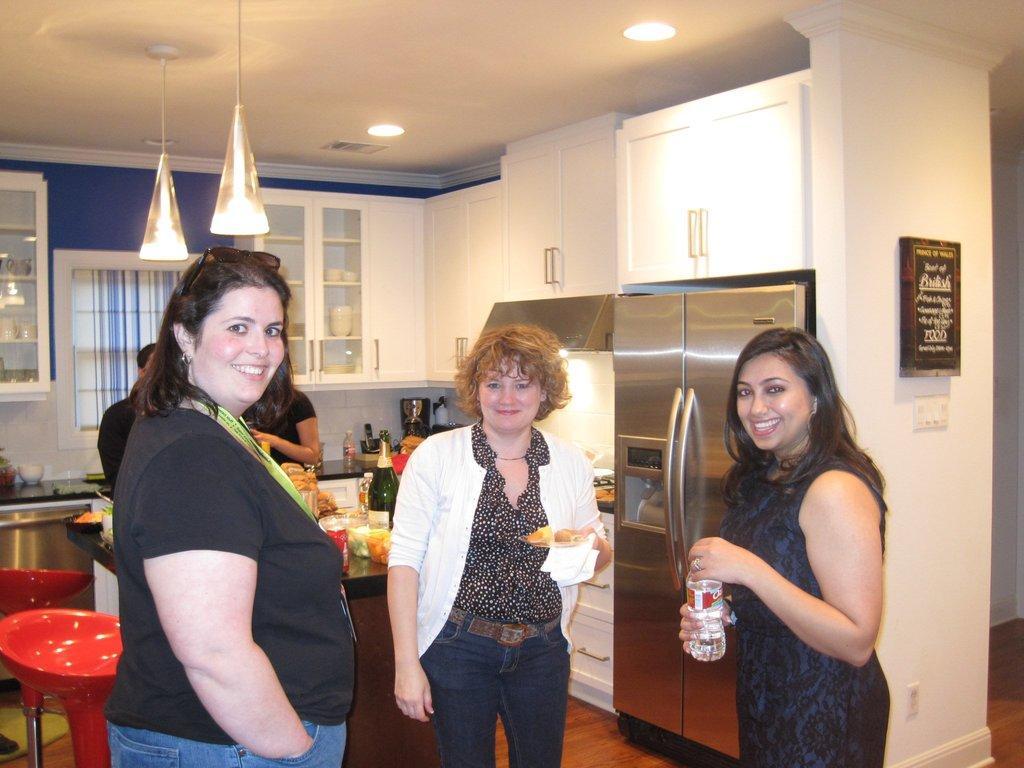How would you summarize this image in a sentence or two? In this image I can see a woman wearing black and blue colored dress, another woman wearing black, blue and white colored dress and a woman wearing black colored dress are standing and holding few objects in their hands. In the background I can see few chairs, a table, few objects on the table, a refrigerator, few lights, the window, the counter top of the kitchen, few cup boards, the wall and the brown colored floor. 